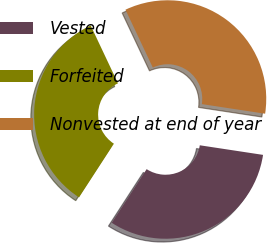Convert chart. <chart><loc_0><loc_0><loc_500><loc_500><pie_chart><fcel>Vested<fcel>Forfeited<fcel>Nonvested at end of year<nl><fcel>31.77%<fcel>33.81%<fcel>34.42%<nl></chart> 